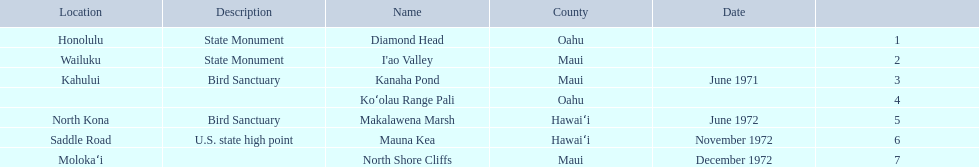What are the national natural landmarks in hawaii? Diamond Head, I'ao Valley, Kanaha Pond, Koʻolau Range Pali, Makalawena Marsh, Mauna Kea, North Shore Cliffs. Which of theses are in hawa'i county? Makalawena Marsh, Mauna Kea. Of these which has a bird sanctuary? Makalawena Marsh. 